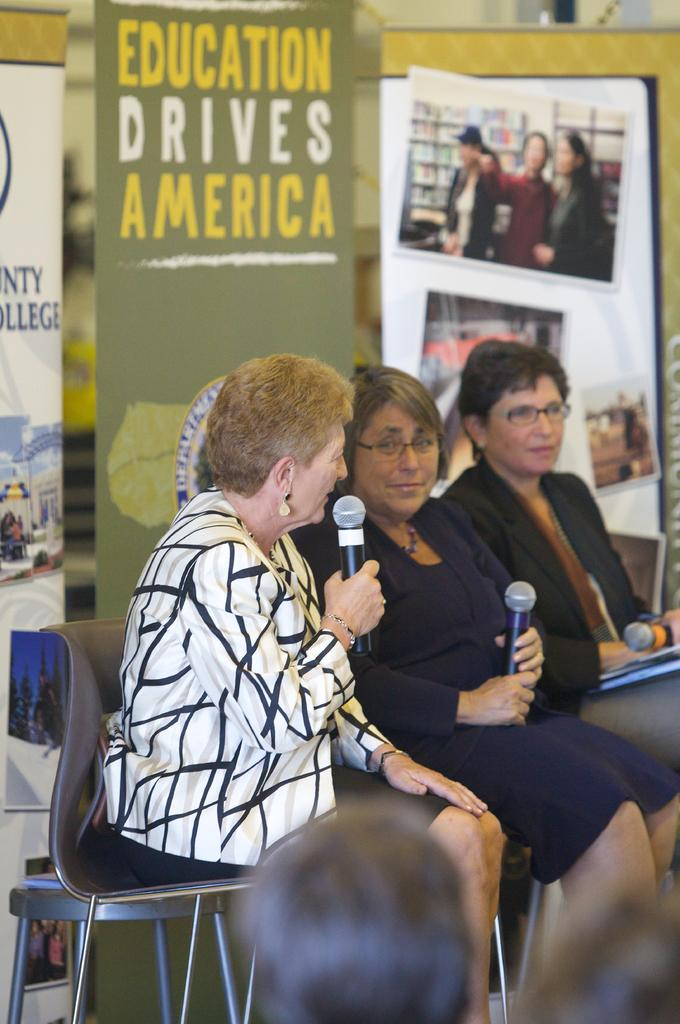How many women are present in the image? There are three women in the image. What are the women doing in the image? The women are sitting on chairs and holding microphones. What can be seen in the background of the image? There are hoardings visible in the background. What type of jam is being discussed by the women in the image? There is no jam or discussion about jam present in the image. What type of land can be seen in the background of the image? There is no land visible in the background of the image; only hoardings are present. 